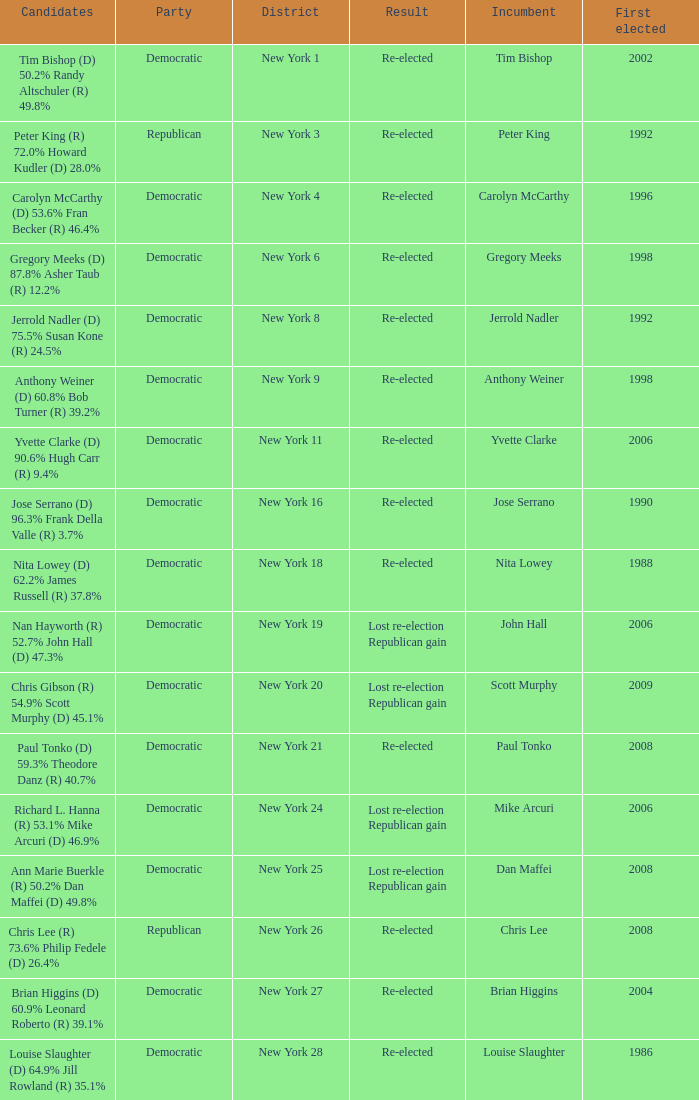Write the full table. {'header': ['Candidates', 'Party', 'District', 'Result', 'Incumbent', 'First elected'], 'rows': [['Tim Bishop (D) 50.2% Randy Altschuler (R) 49.8%', 'Democratic', 'New York 1', 'Re-elected', 'Tim Bishop', '2002'], ['Peter King (R) 72.0% Howard Kudler (D) 28.0%', 'Republican', 'New York 3', 'Re-elected', 'Peter King', '1992'], ['Carolyn McCarthy (D) 53.6% Fran Becker (R) 46.4%', 'Democratic', 'New York 4', 'Re-elected', 'Carolyn McCarthy', '1996'], ['Gregory Meeks (D) 87.8% Asher Taub (R) 12.2%', 'Democratic', 'New York 6', 'Re-elected', 'Gregory Meeks', '1998'], ['Jerrold Nadler (D) 75.5% Susan Kone (R) 24.5%', 'Democratic', 'New York 8', 'Re-elected', 'Jerrold Nadler', '1992'], ['Anthony Weiner (D) 60.8% Bob Turner (R) 39.2%', 'Democratic', 'New York 9', 'Re-elected', 'Anthony Weiner', '1998'], ['Yvette Clarke (D) 90.6% Hugh Carr (R) 9.4%', 'Democratic', 'New York 11', 'Re-elected', 'Yvette Clarke', '2006'], ['Jose Serrano (D) 96.3% Frank Della Valle (R) 3.7%', 'Democratic', 'New York 16', 'Re-elected', 'Jose Serrano', '1990'], ['Nita Lowey (D) 62.2% James Russell (R) 37.8%', 'Democratic', 'New York 18', 'Re-elected', 'Nita Lowey', '1988'], ['Nan Hayworth (R) 52.7% John Hall (D) 47.3%', 'Democratic', 'New York 19', 'Lost re-election Republican gain', 'John Hall', '2006'], ['Chris Gibson (R) 54.9% Scott Murphy (D) 45.1%', 'Democratic', 'New York 20', 'Lost re-election Republican gain', 'Scott Murphy', '2009'], ['Paul Tonko (D) 59.3% Theodore Danz (R) 40.7%', 'Democratic', 'New York 21', 'Re-elected', 'Paul Tonko', '2008'], ['Richard L. Hanna (R) 53.1% Mike Arcuri (D) 46.9%', 'Democratic', 'New York 24', 'Lost re-election Republican gain', 'Mike Arcuri', '2006'], ['Ann Marie Buerkle (R) 50.2% Dan Maffei (D) 49.8%', 'Democratic', 'New York 25', 'Lost re-election Republican gain', 'Dan Maffei', '2008'], ['Chris Lee (R) 73.6% Philip Fedele (D) 26.4%', 'Republican', 'New York 26', 'Re-elected', 'Chris Lee', '2008'], ['Brian Higgins (D) 60.9% Leonard Roberto (R) 39.1%', 'Democratic', 'New York 27', 'Re-elected', 'Brian Higgins', '2004'], ['Louise Slaughter (D) 64.9% Jill Rowland (R) 35.1%', 'Democratic', 'New York 28', 'Re-elected', 'Louise Slaughter', '1986']]} Name the result for new york 8 Re-elected. 